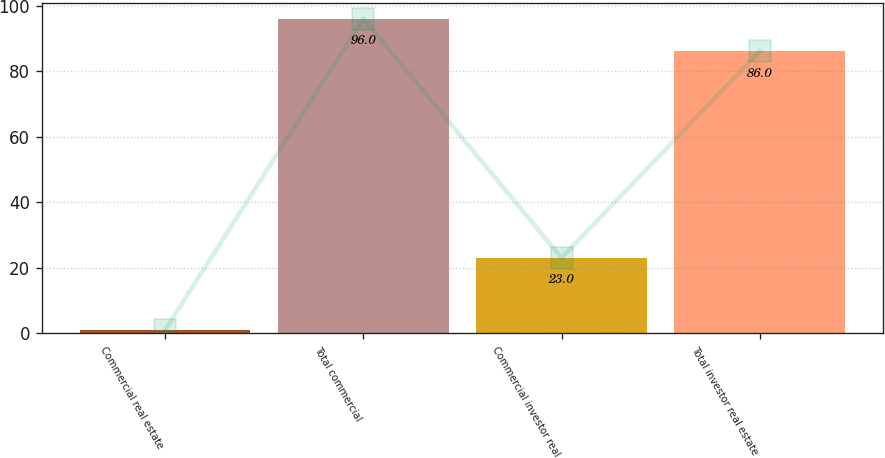<chart> <loc_0><loc_0><loc_500><loc_500><bar_chart><fcel>Commercial real estate<fcel>Total commercial<fcel>Commercial investor real<fcel>Total investor real estate<nl><fcel>1<fcel>96<fcel>23<fcel>86<nl></chart> 